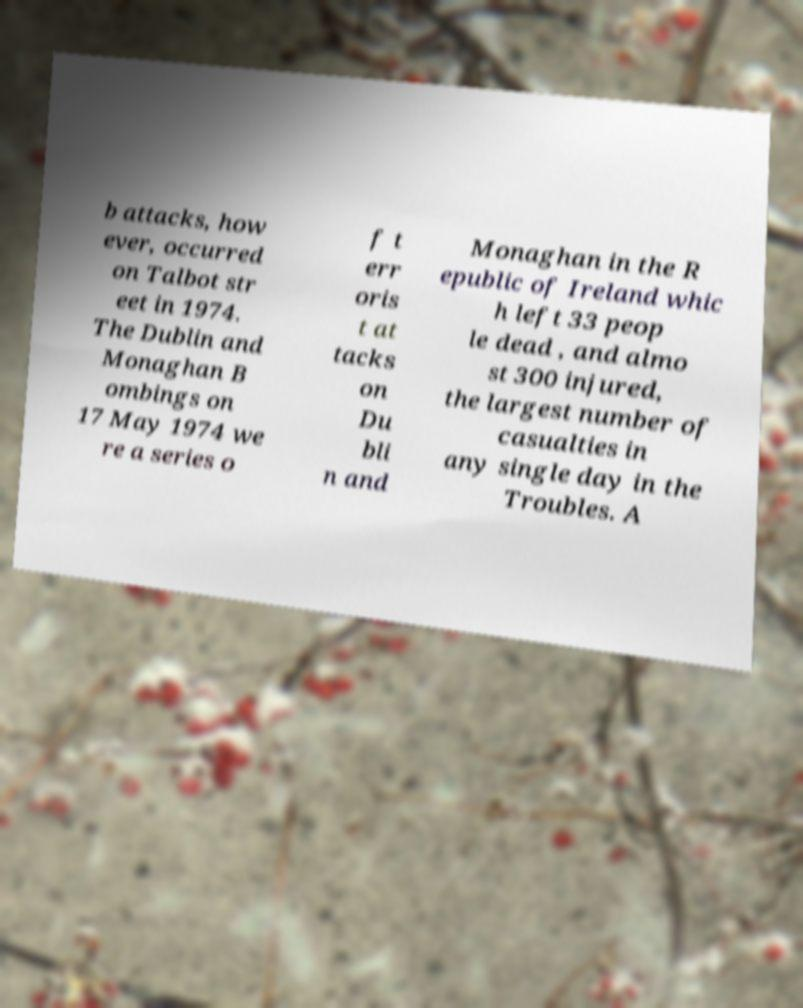Can you read and provide the text displayed in the image?This photo seems to have some interesting text. Can you extract and type it out for me? b attacks, how ever, occurred on Talbot str eet in 1974. The Dublin and Monaghan B ombings on 17 May 1974 we re a series o f t err oris t at tacks on Du bli n and Monaghan in the R epublic of Ireland whic h left 33 peop le dead , and almo st 300 injured, the largest number of casualties in any single day in the Troubles. A 